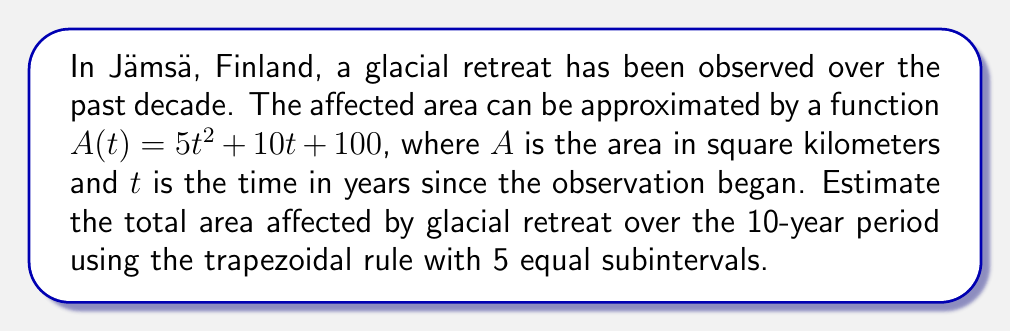Help me with this question. To solve this problem, we'll use the trapezoidal rule to approximate the definite integral of the rate of change of the affected area over the 10-year period.

1) First, we need to find the rate of change of the affected area. This is the derivative of $A(t)$:
   $$A'(t) = 10t + 10$$

2) We want to estimate $\int_0^{10} A'(t) dt$ using the trapezoidal rule with 5 subintervals.

3) The width of each subinterval is:
   $$\Delta t = \frac{10 - 0}{5} = 2$$

4) The t-values for our trapezoids are:
   $t_0 = 0$, $t_1 = 2$, $t_2 = 4$, $t_3 = 6$, $t_4 = 8$, $t_5 = 10$

5) Now we calculate $A'(t)$ for each of these t-values:
   $A'(0) = 10$
   $A'(2) = 30$
   $A'(4) = 50$
   $A'(6) = 70$
   $A'(8) = 90$
   $A'(10) = 110$

6) The trapezoidal rule formula is:
   $$\int_a^b f(x) dx \approx \frac{\Delta x}{2}[f(x_0) + 2f(x_1) + 2f(x_2) + ... + 2f(x_{n-1}) + f(x_n)]$$

7) Applying this to our problem:
   $$\int_0^{10} A'(t) dt \approx \frac{2}{2}[10 + 2(30) + 2(50) + 2(70) + 2(90) + 110]$$
   $$= 1[10 + 60 + 100 + 140 + 180 + 110]$$
   $$= 600$$

8) Therefore, the estimated total area affected by glacial retreat over the 10-year period is approximately 600 square kilometers.
Answer: The estimated total area affected by glacial retreat over the 10-year period is approximately 600 square kilometers. 